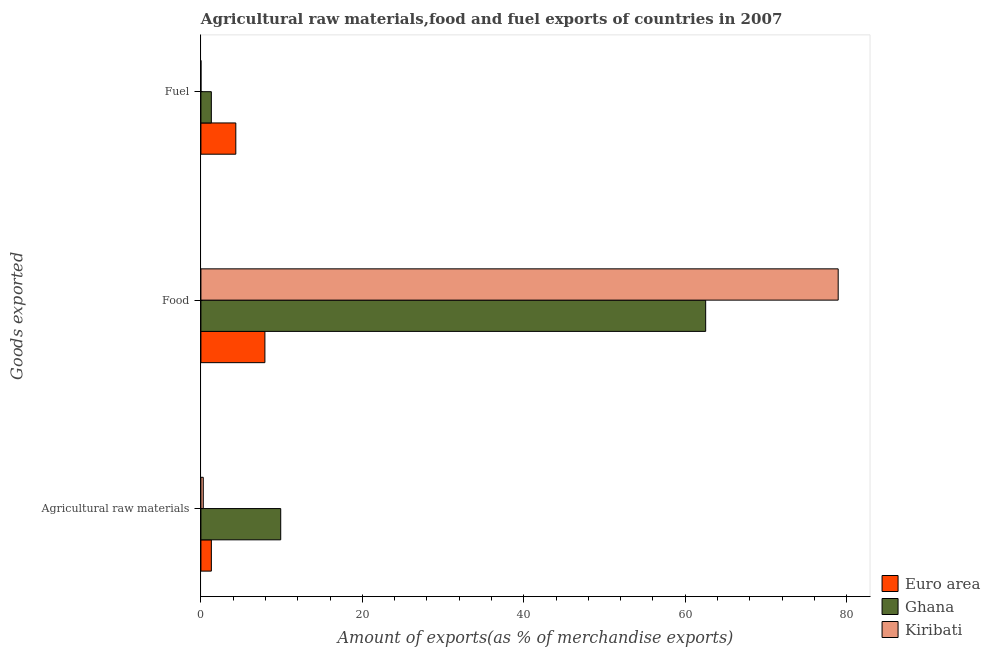How many groups of bars are there?
Offer a very short reply. 3. Are the number of bars per tick equal to the number of legend labels?
Make the answer very short. Yes. Are the number of bars on each tick of the Y-axis equal?
Ensure brevity in your answer.  Yes. How many bars are there on the 2nd tick from the top?
Give a very brief answer. 3. How many bars are there on the 2nd tick from the bottom?
Ensure brevity in your answer.  3. What is the label of the 2nd group of bars from the top?
Ensure brevity in your answer.  Food. What is the percentage of raw materials exports in Ghana?
Make the answer very short. 9.89. Across all countries, what is the maximum percentage of fuel exports?
Your answer should be compact. 4.32. Across all countries, what is the minimum percentage of food exports?
Provide a succinct answer. 7.93. In which country was the percentage of raw materials exports maximum?
Provide a short and direct response. Ghana. In which country was the percentage of food exports minimum?
Give a very brief answer. Euro area. What is the total percentage of raw materials exports in the graph?
Your answer should be very brief. 11.47. What is the difference between the percentage of raw materials exports in Ghana and that in Euro area?
Your answer should be compact. 8.59. What is the difference between the percentage of fuel exports in Ghana and the percentage of raw materials exports in Kiribati?
Ensure brevity in your answer.  1. What is the average percentage of food exports per country?
Make the answer very short. 49.8. What is the difference between the percentage of fuel exports and percentage of food exports in Kiribati?
Give a very brief answer. -78.95. In how many countries, is the percentage of food exports greater than 68 %?
Provide a short and direct response. 1. What is the ratio of the percentage of fuel exports in Kiribati to that in Ghana?
Your answer should be very brief. 0. What is the difference between the highest and the second highest percentage of food exports?
Your answer should be very brief. 16.42. What is the difference between the highest and the lowest percentage of fuel exports?
Your response must be concise. 4.32. In how many countries, is the percentage of food exports greater than the average percentage of food exports taken over all countries?
Offer a terse response. 2. What does the 3rd bar from the top in Fuel represents?
Your response must be concise. Euro area. What does the 2nd bar from the bottom in Fuel represents?
Your response must be concise. Ghana. Are all the bars in the graph horizontal?
Keep it short and to the point. Yes. How many countries are there in the graph?
Provide a succinct answer. 3. What is the difference between two consecutive major ticks on the X-axis?
Your answer should be very brief. 20. Are the values on the major ticks of X-axis written in scientific E-notation?
Your answer should be very brief. No. Does the graph contain any zero values?
Offer a terse response. No. Does the graph contain grids?
Keep it short and to the point. No. Where does the legend appear in the graph?
Ensure brevity in your answer.  Bottom right. What is the title of the graph?
Keep it short and to the point. Agricultural raw materials,food and fuel exports of countries in 2007. What is the label or title of the X-axis?
Ensure brevity in your answer.  Amount of exports(as % of merchandise exports). What is the label or title of the Y-axis?
Make the answer very short. Goods exported. What is the Amount of exports(as % of merchandise exports) in Euro area in Agricultural raw materials?
Ensure brevity in your answer.  1.29. What is the Amount of exports(as % of merchandise exports) in Ghana in Agricultural raw materials?
Your answer should be compact. 9.89. What is the Amount of exports(as % of merchandise exports) of Kiribati in Agricultural raw materials?
Provide a short and direct response. 0.29. What is the Amount of exports(as % of merchandise exports) of Euro area in Food?
Make the answer very short. 7.93. What is the Amount of exports(as % of merchandise exports) in Ghana in Food?
Your answer should be very brief. 62.53. What is the Amount of exports(as % of merchandise exports) in Kiribati in Food?
Give a very brief answer. 78.95. What is the Amount of exports(as % of merchandise exports) in Euro area in Fuel?
Make the answer very short. 4.32. What is the Amount of exports(as % of merchandise exports) in Ghana in Fuel?
Provide a succinct answer. 1.29. What is the Amount of exports(as % of merchandise exports) of Kiribati in Fuel?
Keep it short and to the point. 0. Across all Goods exported, what is the maximum Amount of exports(as % of merchandise exports) in Euro area?
Keep it short and to the point. 7.93. Across all Goods exported, what is the maximum Amount of exports(as % of merchandise exports) of Ghana?
Provide a succinct answer. 62.53. Across all Goods exported, what is the maximum Amount of exports(as % of merchandise exports) in Kiribati?
Make the answer very short. 78.95. Across all Goods exported, what is the minimum Amount of exports(as % of merchandise exports) in Euro area?
Ensure brevity in your answer.  1.29. Across all Goods exported, what is the minimum Amount of exports(as % of merchandise exports) in Ghana?
Your answer should be compact. 1.29. Across all Goods exported, what is the minimum Amount of exports(as % of merchandise exports) of Kiribati?
Offer a terse response. 0. What is the total Amount of exports(as % of merchandise exports) in Euro area in the graph?
Your answer should be compact. 13.54. What is the total Amount of exports(as % of merchandise exports) of Ghana in the graph?
Provide a short and direct response. 73.71. What is the total Amount of exports(as % of merchandise exports) in Kiribati in the graph?
Provide a succinct answer. 79.25. What is the difference between the Amount of exports(as % of merchandise exports) of Euro area in Agricultural raw materials and that in Food?
Ensure brevity in your answer.  -6.63. What is the difference between the Amount of exports(as % of merchandise exports) in Ghana in Agricultural raw materials and that in Food?
Make the answer very short. -52.65. What is the difference between the Amount of exports(as % of merchandise exports) in Kiribati in Agricultural raw materials and that in Food?
Your answer should be compact. -78.66. What is the difference between the Amount of exports(as % of merchandise exports) in Euro area in Agricultural raw materials and that in Fuel?
Provide a succinct answer. -3.03. What is the difference between the Amount of exports(as % of merchandise exports) of Ghana in Agricultural raw materials and that in Fuel?
Your answer should be very brief. 8.6. What is the difference between the Amount of exports(as % of merchandise exports) in Kiribati in Agricultural raw materials and that in Fuel?
Offer a very short reply. 0.29. What is the difference between the Amount of exports(as % of merchandise exports) in Euro area in Food and that in Fuel?
Give a very brief answer. 3.6. What is the difference between the Amount of exports(as % of merchandise exports) in Ghana in Food and that in Fuel?
Offer a terse response. 61.24. What is the difference between the Amount of exports(as % of merchandise exports) in Kiribati in Food and that in Fuel?
Give a very brief answer. 78.95. What is the difference between the Amount of exports(as % of merchandise exports) of Euro area in Agricultural raw materials and the Amount of exports(as % of merchandise exports) of Ghana in Food?
Provide a short and direct response. -61.24. What is the difference between the Amount of exports(as % of merchandise exports) in Euro area in Agricultural raw materials and the Amount of exports(as % of merchandise exports) in Kiribati in Food?
Ensure brevity in your answer.  -77.66. What is the difference between the Amount of exports(as % of merchandise exports) of Ghana in Agricultural raw materials and the Amount of exports(as % of merchandise exports) of Kiribati in Food?
Offer a very short reply. -69.06. What is the difference between the Amount of exports(as % of merchandise exports) of Euro area in Agricultural raw materials and the Amount of exports(as % of merchandise exports) of Ghana in Fuel?
Ensure brevity in your answer.  0. What is the difference between the Amount of exports(as % of merchandise exports) of Euro area in Agricultural raw materials and the Amount of exports(as % of merchandise exports) of Kiribati in Fuel?
Your response must be concise. 1.29. What is the difference between the Amount of exports(as % of merchandise exports) in Ghana in Agricultural raw materials and the Amount of exports(as % of merchandise exports) in Kiribati in Fuel?
Provide a short and direct response. 9.89. What is the difference between the Amount of exports(as % of merchandise exports) in Euro area in Food and the Amount of exports(as % of merchandise exports) in Ghana in Fuel?
Provide a succinct answer. 6.64. What is the difference between the Amount of exports(as % of merchandise exports) of Euro area in Food and the Amount of exports(as % of merchandise exports) of Kiribati in Fuel?
Your answer should be very brief. 7.93. What is the difference between the Amount of exports(as % of merchandise exports) of Ghana in Food and the Amount of exports(as % of merchandise exports) of Kiribati in Fuel?
Give a very brief answer. 62.53. What is the average Amount of exports(as % of merchandise exports) of Euro area per Goods exported?
Provide a succinct answer. 4.51. What is the average Amount of exports(as % of merchandise exports) in Ghana per Goods exported?
Provide a succinct answer. 24.57. What is the average Amount of exports(as % of merchandise exports) of Kiribati per Goods exported?
Make the answer very short. 26.42. What is the difference between the Amount of exports(as % of merchandise exports) of Euro area and Amount of exports(as % of merchandise exports) of Ghana in Agricultural raw materials?
Offer a very short reply. -8.59. What is the difference between the Amount of exports(as % of merchandise exports) in Euro area and Amount of exports(as % of merchandise exports) in Kiribati in Agricultural raw materials?
Your response must be concise. 1. What is the difference between the Amount of exports(as % of merchandise exports) in Ghana and Amount of exports(as % of merchandise exports) in Kiribati in Agricultural raw materials?
Keep it short and to the point. 9.59. What is the difference between the Amount of exports(as % of merchandise exports) of Euro area and Amount of exports(as % of merchandise exports) of Ghana in Food?
Keep it short and to the point. -54.61. What is the difference between the Amount of exports(as % of merchandise exports) in Euro area and Amount of exports(as % of merchandise exports) in Kiribati in Food?
Keep it short and to the point. -71.02. What is the difference between the Amount of exports(as % of merchandise exports) in Ghana and Amount of exports(as % of merchandise exports) in Kiribati in Food?
Offer a very short reply. -16.42. What is the difference between the Amount of exports(as % of merchandise exports) in Euro area and Amount of exports(as % of merchandise exports) in Ghana in Fuel?
Offer a very short reply. 3.03. What is the difference between the Amount of exports(as % of merchandise exports) in Euro area and Amount of exports(as % of merchandise exports) in Kiribati in Fuel?
Provide a short and direct response. 4.32. What is the difference between the Amount of exports(as % of merchandise exports) in Ghana and Amount of exports(as % of merchandise exports) in Kiribati in Fuel?
Your response must be concise. 1.29. What is the ratio of the Amount of exports(as % of merchandise exports) of Euro area in Agricultural raw materials to that in Food?
Give a very brief answer. 0.16. What is the ratio of the Amount of exports(as % of merchandise exports) of Ghana in Agricultural raw materials to that in Food?
Offer a terse response. 0.16. What is the ratio of the Amount of exports(as % of merchandise exports) of Kiribati in Agricultural raw materials to that in Food?
Provide a short and direct response. 0. What is the ratio of the Amount of exports(as % of merchandise exports) in Euro area in Agricultural raw materials to that in Fuel?
Make the answer very short. 0.3. What is the ratio of the Amount of exports(as % of merchandise exports) of Ghana in Agricultural raw materials to that in Fuel?
Give a very brief answer. 7.65. What is the ratio of the Amount of exports(as % of merchandise exports) of Kiribati in Agricultural raw materials to that in Fuel?
Keep it short and to the point. 1189.52. What is the ratio of the Amount of exports(as % of merchandise exports) of Euro area in Food to that in Fuel?
Your answer should be very brief. 1.83. What is the ratio of the Amount of exports(as % of merchandise exports) in Ghana in Food to that in Fuel?
Your answer should be compact. 48.39. What is the ratio of the Amount of exports(as % of merchandise exports) of Kiribati in Food to that in Fuel?
Keep it short and to the point. 3.20e+05. What is the difference between the highest and the second highest Amount of exports(as % of merchandise exports) in Euro area?
Ensure brevity in your answer.  3.6. What is the difference between the highest and the second highest Amount of exports(as % of merchandise exports) of Ghana?
Your answer should be very brief. 52.65. What is the difference between the highest and the second highest Amount of exports(as % of merchandise exports) in Kiribati?
Your response must be concise. 78.66. What is the difference between the highest and the lowest Amount of exports(as % of merchandise exports) of Euro area?
Your response must be concise. 6.63. What is the difference between the highest and the lowest Amount of exports(as % of merchandise exports) of Ghana?
Your answer should be very brief. 61.24. What is the difference between the highest and the lowest Amount of exports(as % of merchandise exports) in Kiribati?
Your response must be concise. 78.95. 